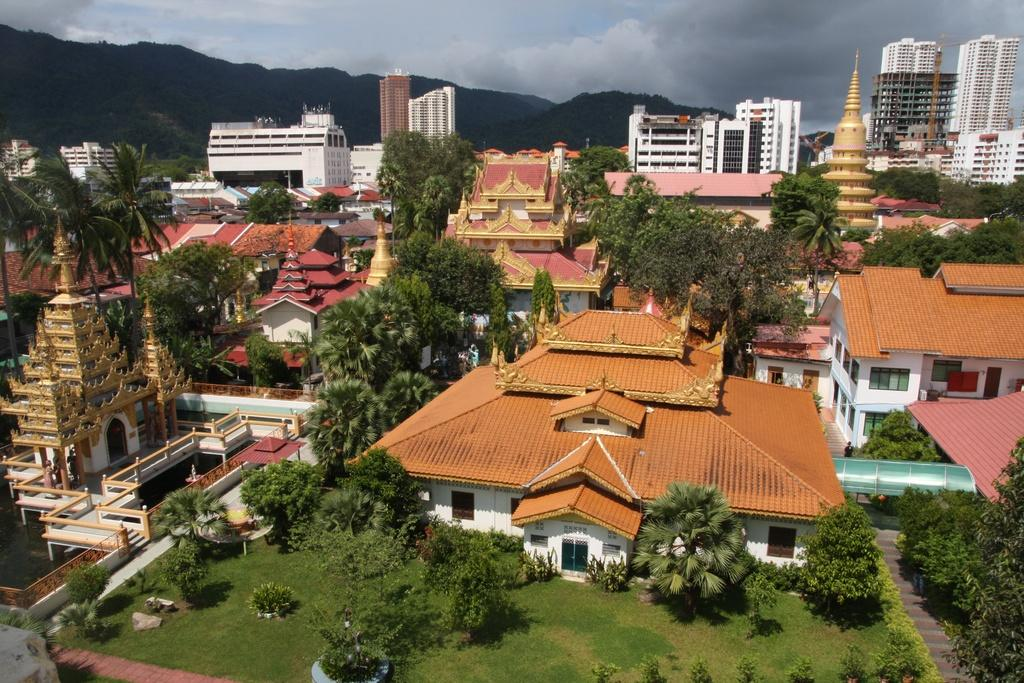What type of structures can be seen in the image? There are houses and buildings in the image. What natural elements are present in the image? There are trees, plants, grass, and mountains in the image. What architectural features can be seen on the structures? There are windows and doors in the image. What is the condition of the sky in the image? The sky is visible and appears cloudy in the image. What type of tooth is being used to give advice in the image? There is no tooth or advice-giving activity present in the image. 